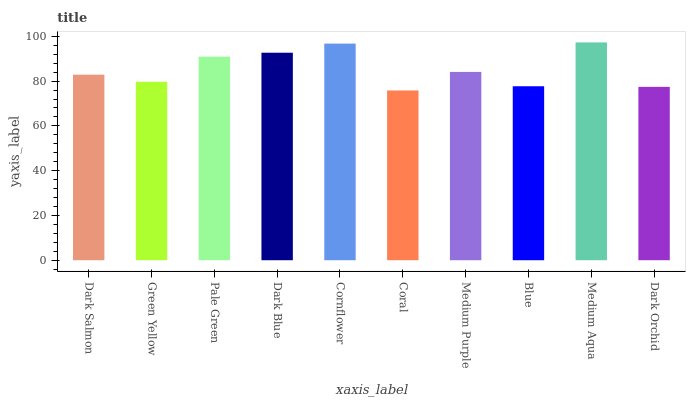Is Coral the minimum?
Answer yes or no. Yes. Is Medium Aqua the maximum?
Answer yes or no. Yes. Is Green Yellow the minimum?
Answer yes or no. No. Is Green Yellow the maximum?
Answer yes or no. No. Is Dark Salmon greater than Green Yellow?
Answer yes or no. Yes. Is Green Yellow less than Dark Salmon?
Answer yes or no. Yes. Is Green Yellow greater than Dark Salmon?
Answer yes or no. No. Is Dark Salmon less than Green Yellow?
Answer yes or no. No. Is Medium Purple the high median?
Answer yes or no. Yes. Is Dark Salmon the low median?
Answer yes or no. Yes. Is Cornflower the high median?
Answer yes or no. No. Is Green Yellow the low median?
Answer yes or no. No. 